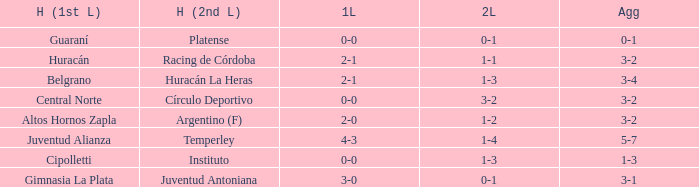What was the score of the 2nd leg when the Belgrano played the first leg at home with a score of 2-1? 1-3. 